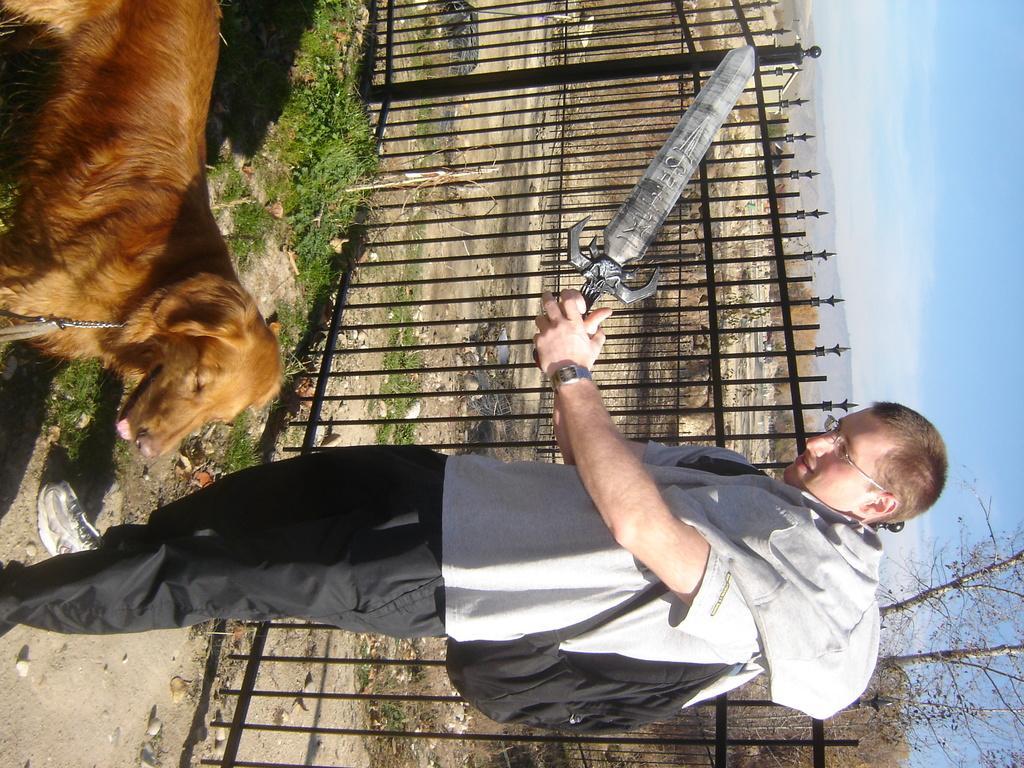Describe this image in one or two sentences. This image is in right direction. In this image I can see a man wearing t-shirt, trouser, shoes, bag and standing. He is holding a sword in the hands and looking at the dog which is in front of him. At the back of this man I can see the railing. On the right side, I can see the sky. 